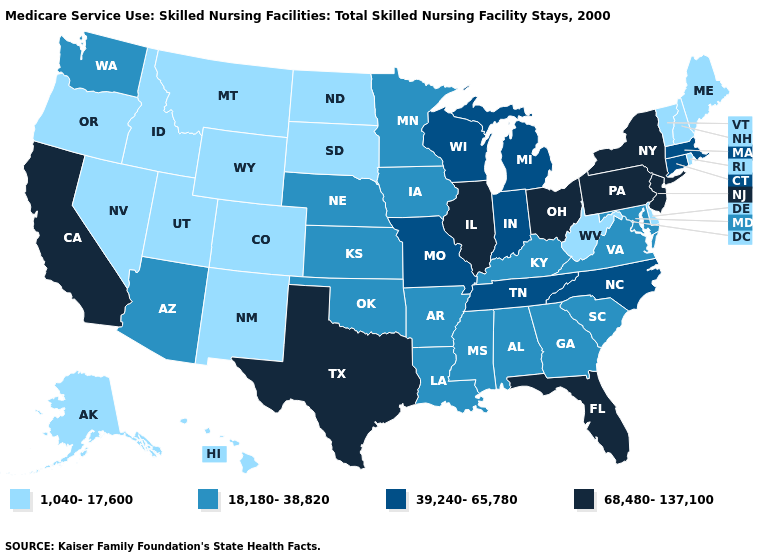Does Delaware have the lowest value in the South?
Concise answer only. Yes. What is the value of Michigan?
Quick response, please. 39,240-65,780. Does Utah have a lower value than Oregon?
Be succinct. No. What is the value of Minnesota?
Write a very short answer. 18,180-38,820. What is the lowest value in the Northeast?
Write a very short answer. 1,040-17,600. Among the states that border Kentucky , which have the highest value?
Short answer required. Illinois, Ohio. Name the states that have a value in the range 68,480-137,100?
Quick response, please. California, Florida, Illinois, New Jersey, New York, Ohio, Pennsylvania, Texas. Name the states that have a value in the range 68,480-137,100?
Keep it brief. California, Florida, Illinois, New Jersey, New York, Ohio, Pennsylvania, Texas. Does North Dakota have the lowest value in the MidWest?
Be succinct. Yes. Among the states that border Louisiana , does Mississippi have the lowest value?
Write a very short answer. Yes. What is the highest value in states that border Indiana?
Quick response, please. 68,480-137,100. Does the map have missing data?
Answer briefly. No. Name the states that have a value in the range 39,240-65,780?
Be succinct. Connecticut, Indiana, Massachusetts, Michigan, Missouri, North Carolina, Tennessee, Wisconsin. Does California have the highest value in the West?
Give a very brief answer. Yes. 